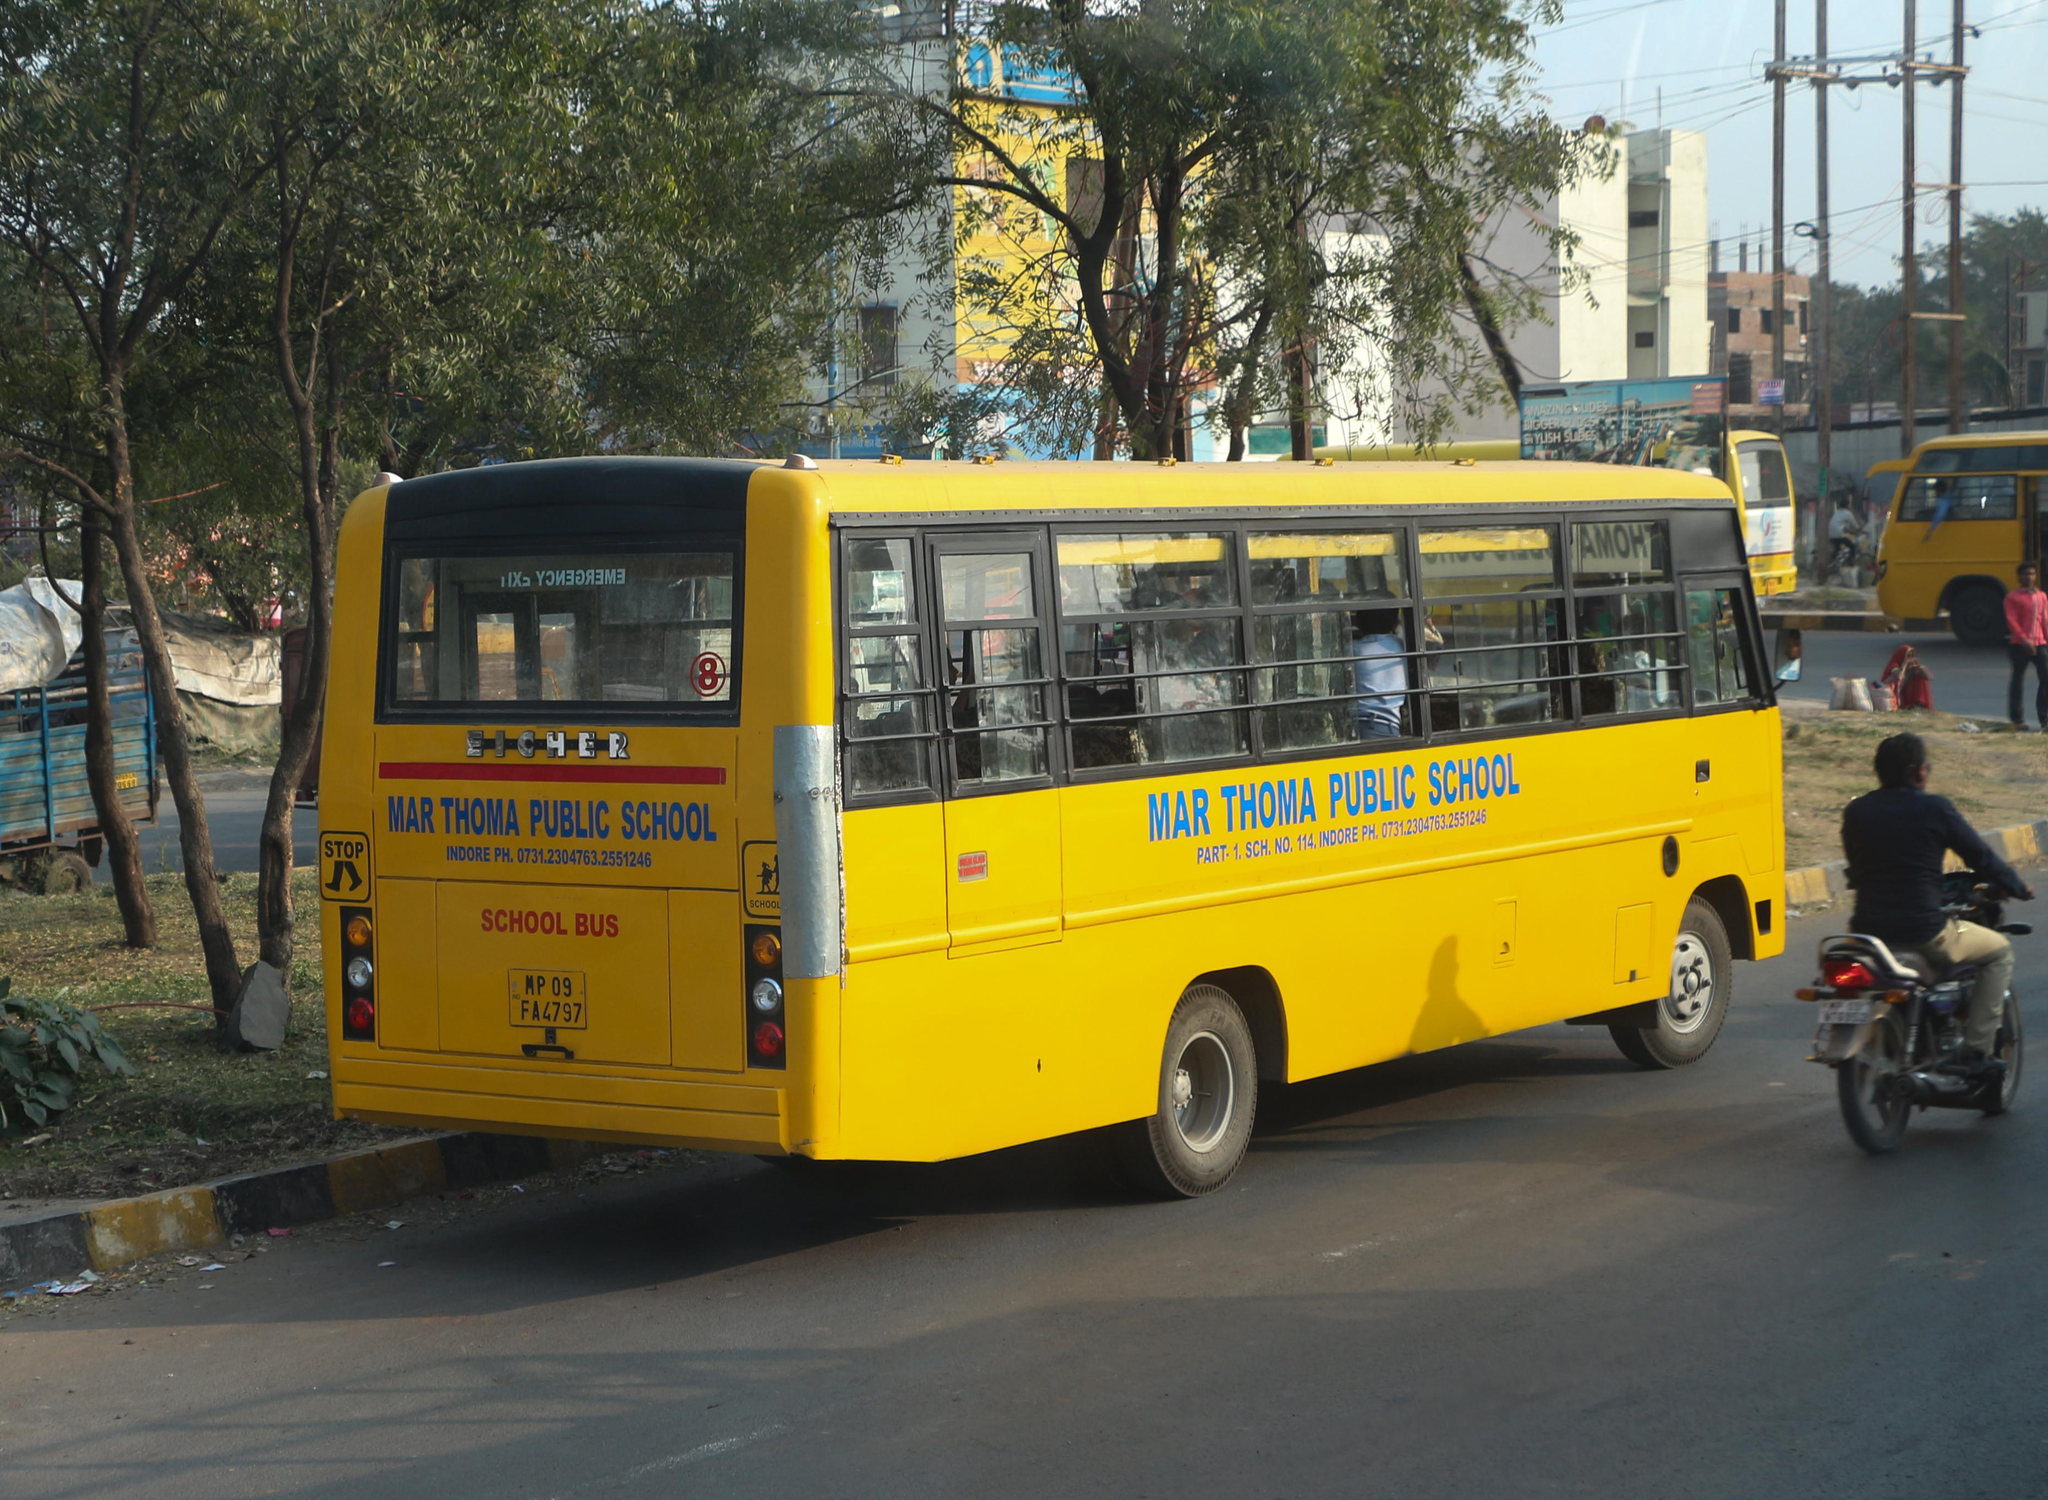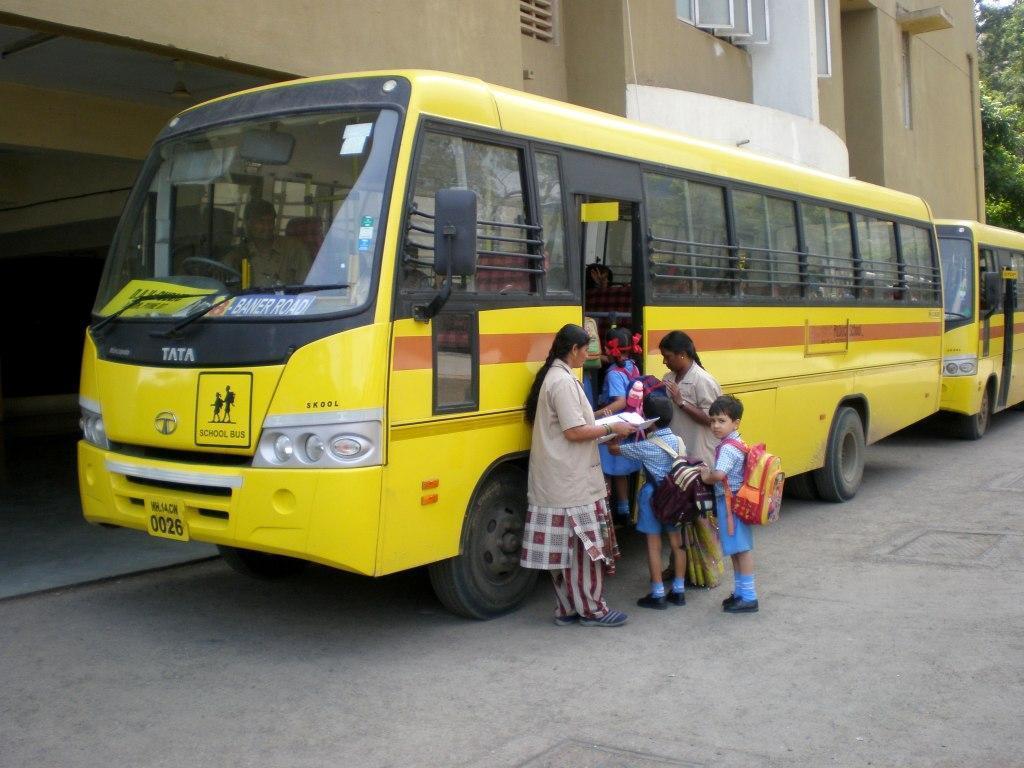The first image is the image on the left, the second image is the image on the right. Evaluate the accuracy of this statement regarding the images: "One of the pictures shows at least six school buses parked next to each other.". Is it true? Answer yes or no. No. 